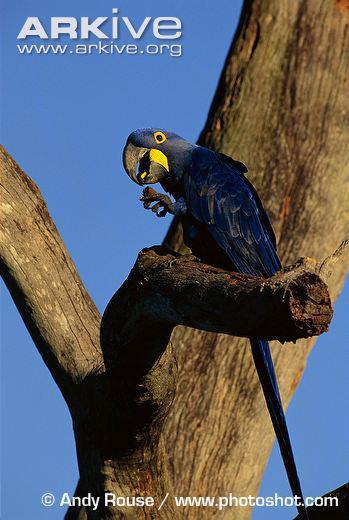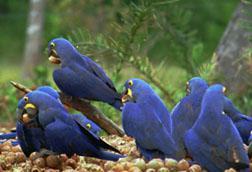The first image is the image on the left, the second image is the image on the right. Considering the images on both sides, is "An image shows one blue parrot perched on a stub-ended leafless branch." valid? Answer yes or no. Yes. The first image is the image on the left, the second image is the image on the right. Analyze the images presented: Is the assertion "The right image contains no more than one blue parrot that is facing towards the left." valid? Answer yes or no. No. 